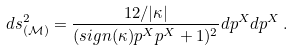Convert formula to latex. <formula><loc_0><loc_0><loc_500><loc_500>d s ^ { 2 } _ { ( \mathcal { M } ) } = \frac { 1 2 / | \kappa | } { ( s i g n ( \kappa ) p ^ { X } p ^ { X } + 1 ) ^ { 2 } } d p ^ { X } d p ^ { X } \, .</formula> 